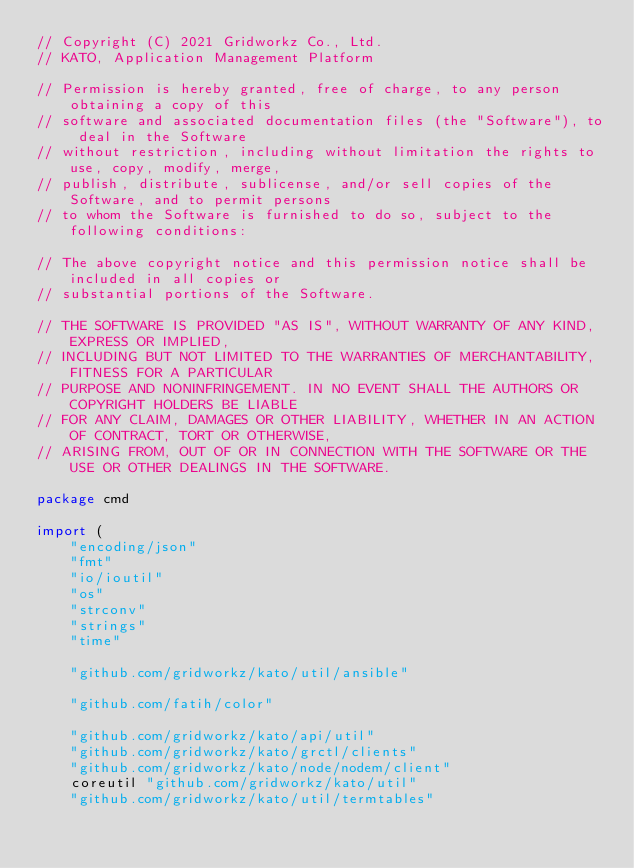<code> <loc_0><loc_0><loc_500><loc_500><_Go_>// Copyright (C) 2021 Gridworkz Co., Ltd.
// KATO, Application Management Platform

// Permission is hereby granted, free of charge, to any person obtaining a copy of this 
// software and associated documentation files (the "Software"), to deal in the Software
// without restriction, including without limitation the rights to use, copy, modify, merge,
// publish, distribute, sublicense, and/or sell copies of the Software, and to permit persons 
// to whom the Software is furnished to do so, subject to the following conditions:

// The above copyright notice and this permission notice shall be included in all copies or 
// substantial portions of the Software.

// THE SOFTWARE IS PROVIDED "AS IS", WITHOUT WARRANTY OF ANY KIND, EXPRESS OR IMPLIED, 
// INCLUDING BUT NOT LIMITED TO THE WARRANTIES OF MERCHANTABILITY, FITNESS FOR A PARTICULAR
// PURPOSE AND NONINFRINGEMENT. IN NO EVENT SHALL THE AUTHORS OR COPYRIGHT HOLDERS BE LIABLE
// FOR ANY CLAIM, DAMAGES OR OTHER LIABILITY, WHETHER IN AN ACTION OF CONTRACT, TORT OR OTHERWISE,
// ARISING FROM, OUT OF OR IN CONNECTION WITH THE SOFTWARE OR THE USE OR OTHER DEALINGS IN THE SOFTWARE.

package cmd

import (
	"encoding/json"
	"fmt"
	"io/ioutil"
	"os"
	"strconv"
	"strings"
	"time"

	"github.com/gridworkz/kato/util/ansible"

	"github.com/fatih/color"

	"github.com/gridworkz/kato/api/util"
	"github.com/gridworkz/kato/grctl/clients"
	"github.com/gridworkz/kato/node/nodem/client"
	coreutil "github.com/gridworkz/kato/util"
	"github.com/gridworkz/kato/util/termtables"</code> 